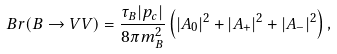Convert formula to latex. <formula><loc_0><loc_0><loc_500><loc_500>B r ( B \to V V ) = \frac { \tau _ { B } | p _ { c } | } { 8 \pi m ^ { 2 } _ { B } } \left ( | A _ { 0 } | ^ { 2 } + | A _ { + } | ^ { 2 } + | A _ { - } | ^ { 2 } \right ) ,</formula> 